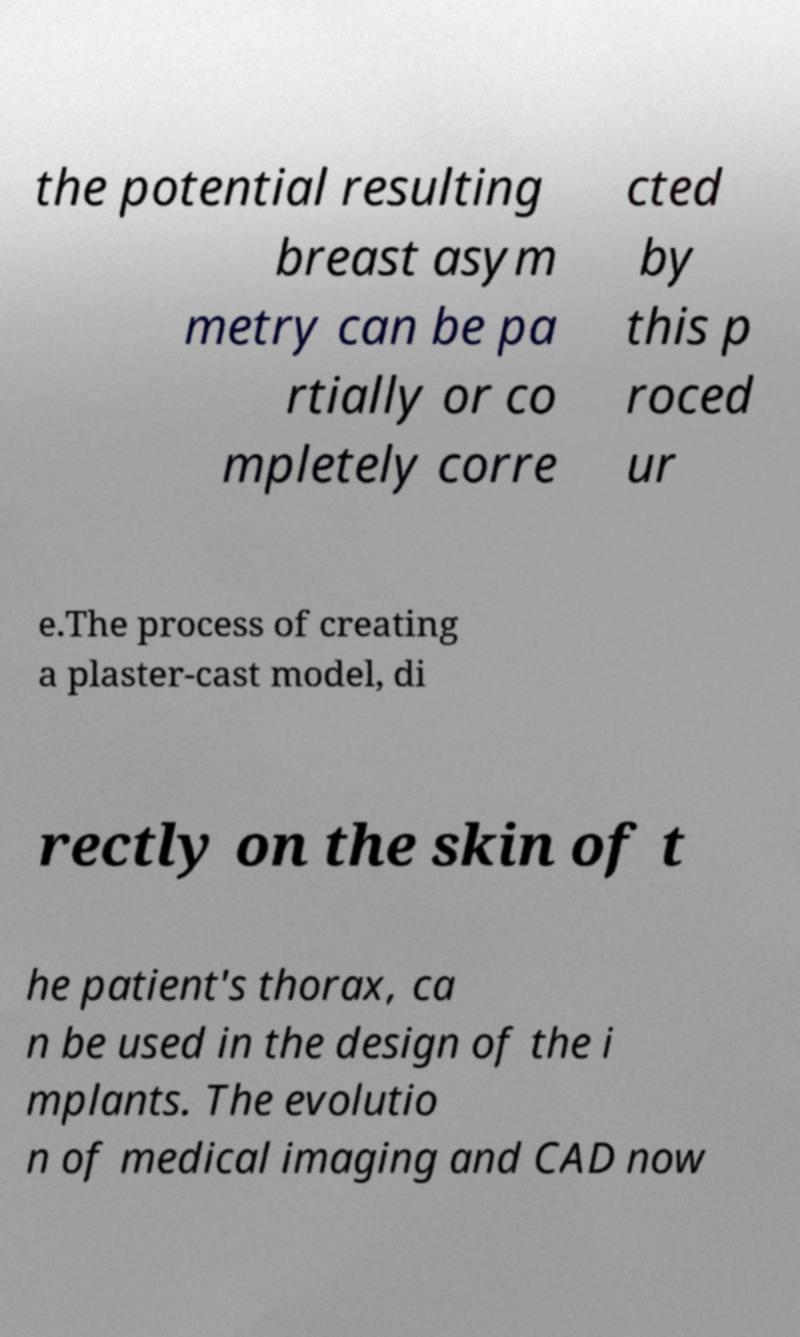Please read and relay the text visible in this image. What does it say? the potential resulting breast asym metry can be pa rtially or co mpletely corre cted by this p roced ur e.The process of creating a plaster-cast model, di rectly on the skin of t he patient's thorax, ca n be used in the design of the i mplants. The evolutio n of medical imaging and CAD now 